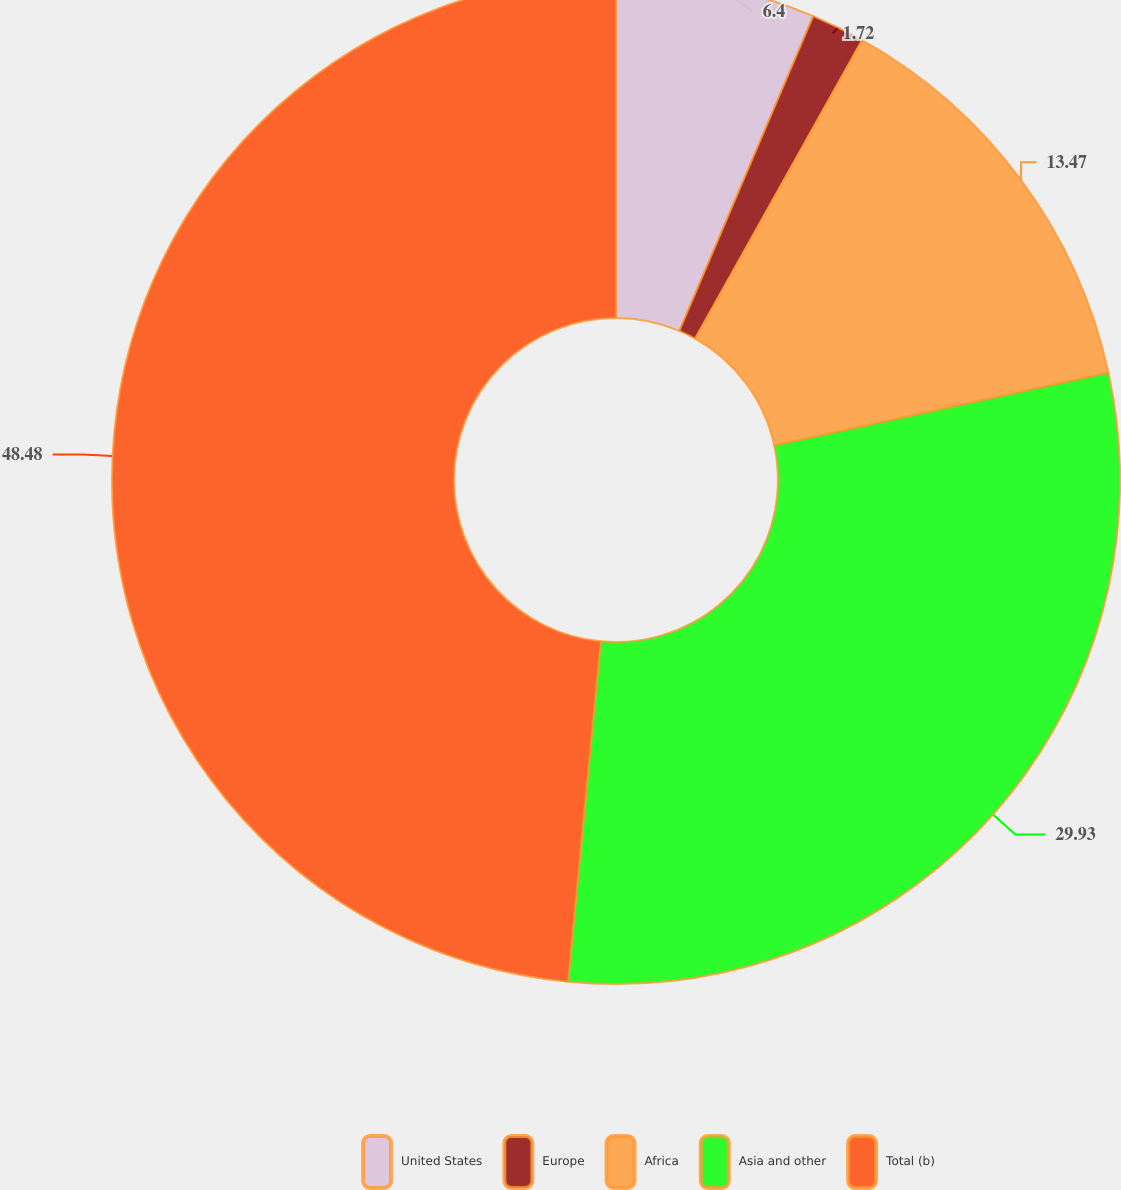Convert chart. <chart><loc_0><loc_0><loc_500><loc_500><pie_chart><fcel>United States<fcel>Europe<fcel>Africa<fcel>Asia and other<fcel>Total (b)<nl><fcel>6.4%<fcel>1.72%<fcel>13.47%<fcel>29.93%<fcel>48.48%<nl></chart> 